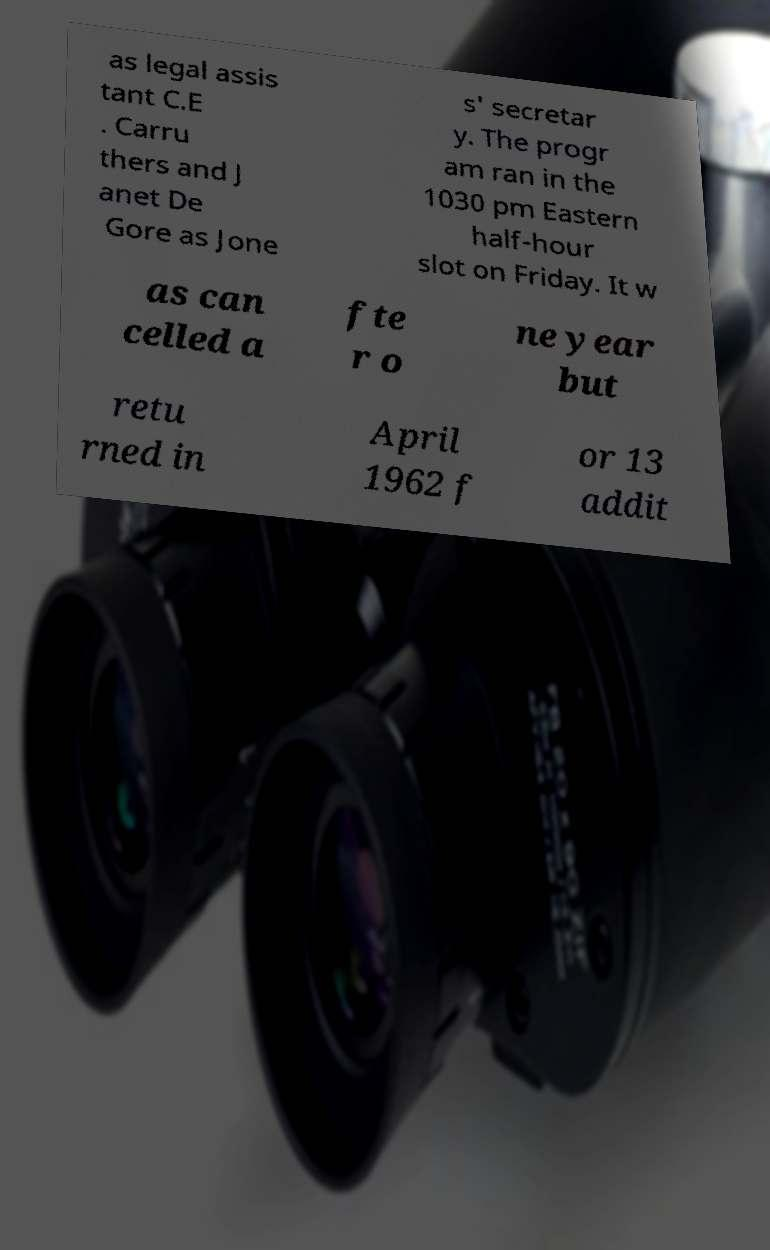There's text embedded in this image that I need extracted. Can you transcribe it verbatim? as legal assis tant C.E . Carru thers and J anet De Gore as Jone s' secretar y. The progr am ran in the 1030 pm Eastern half-hour slot on Friday. It w as can celled a fte r o ne year but retu rned in April 1962 f or 13 addit 